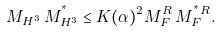Convert formula to latex. <formula><loc_0><loc_0><loc_500><loc_500>M _ { H ^ { 3 } } \, M _ { H ^ { 3 } } ^ { ^ { * } } \leq K ( \alpha ) ^ { 2 } M _ { F } ^ { R } \, M _ { F } ^ { ^ { * } R } .</formula> 